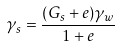Convert formula to latex. <formula><loc_0><loc_0><loc_500><loc_500>\gamma _ { s } = \frac { ( G _ { s } + e ) \gamma _ { w } } { 1 + e }</formula> 